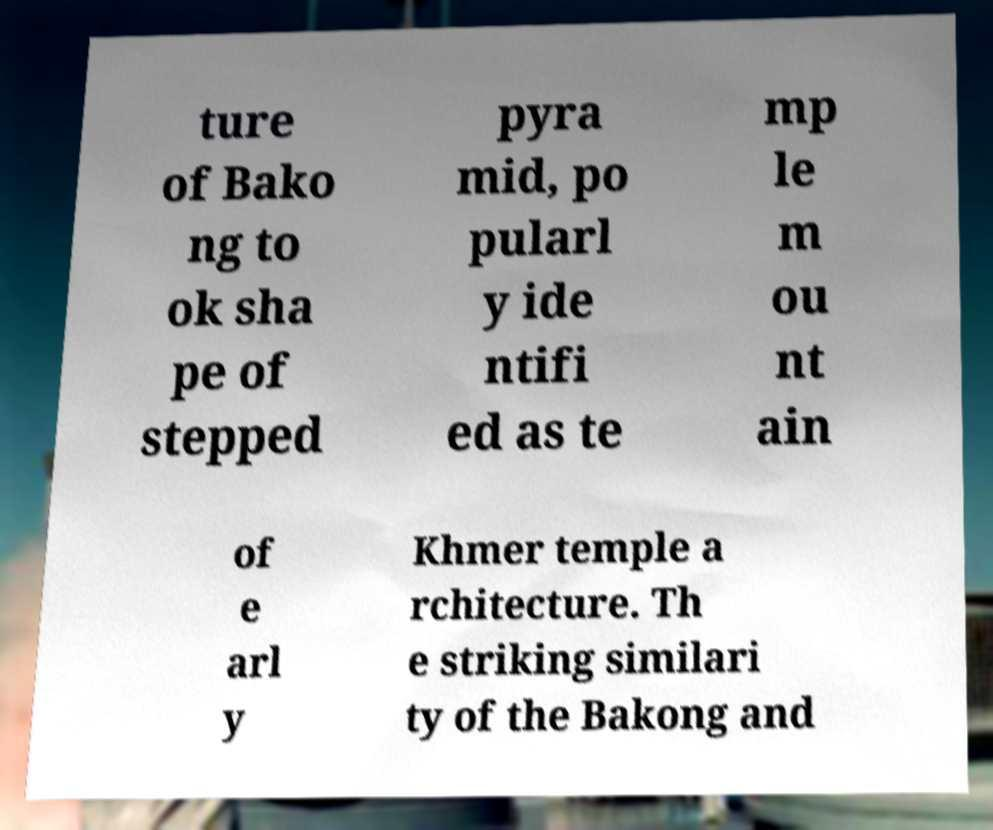Can you accurately transcribe the text from the provided image for me? ture of Bako ng to ok sha pe of stepped pyra mid, po pularl y ide ntifi ed as te mp le m ou nt ain of e arl y Khmer temple a rchitecture. Th e striking similari ty of the Bakong and 